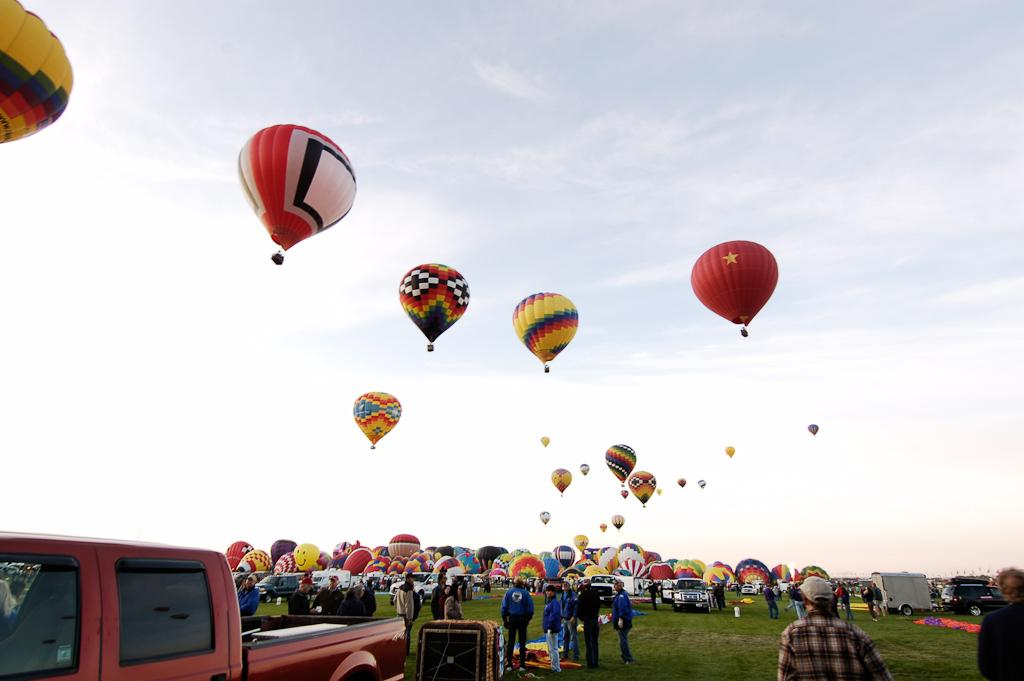Who or what is present in the image? There are people in the image. What are the people using in the image? There are parachutes in the image, and some of them are flying in the sky. What else can be seen in the image besides people and parachutes? There are vehicles in the image. Can you tell me how many babies were born during the earthquake depicted in the image? There is no earthquake or any reference to a birth event in the image; it features people using parachutes and vehicles. 